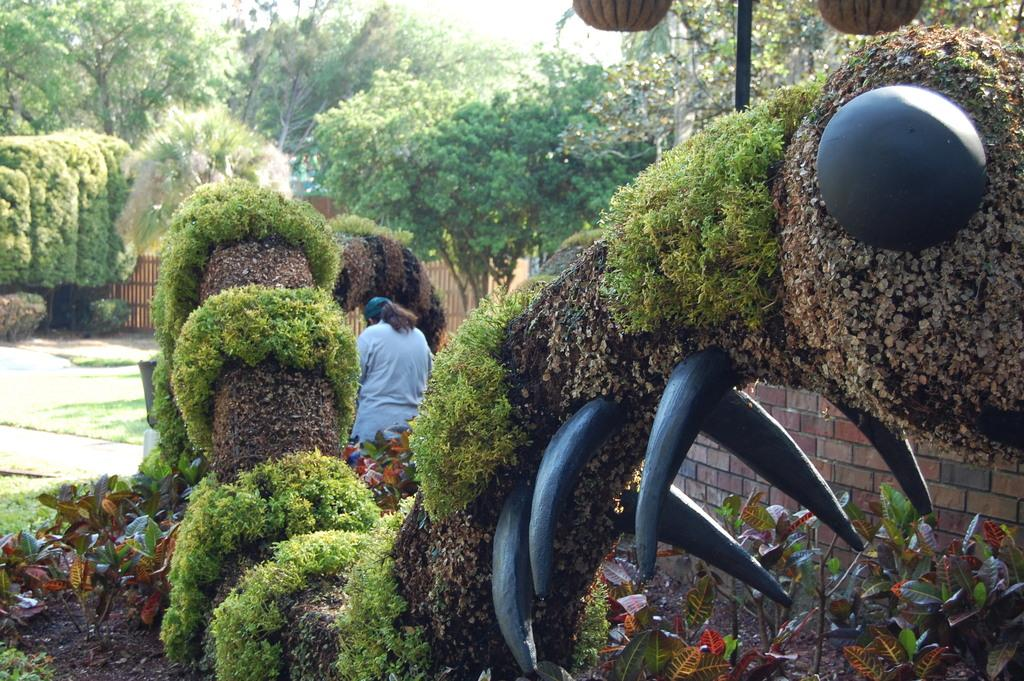What can be seen in the image? There is a person in the image, along with grass, a plant, trees, a fence, a pole, and an object. Can you describe the person's attire in the image? The person is wearing clothes and a cap. What type of vegetation is present in the image? There is grass, a plant, and trees in the image. What structures can be seen in the image? There is a fence and a pole in the image. What is the unidentified object in the image? The object in the image is not described in the facts, so we cannot provide any details about it. How does the person twist the stone in the image? There is no stone present in the image, so the person cannot twist any stone. 